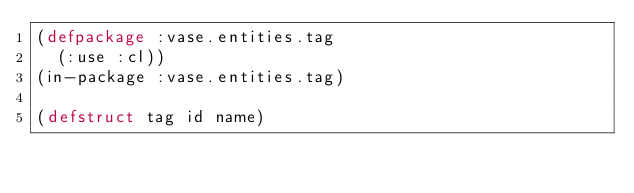Convert code to text. <code><loc_0><loc_0><loc_500><loc_500><_Lisp_>(defpackage :vase.entities.tag
  (:use :cl))
(in-package :vase.entities.tag)

(defstruct tag id name)
</code> 